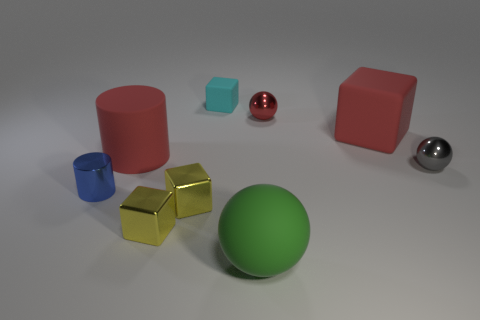Are there more rubber blocks that are left of the tiny rubber thing than tiny red things that are right of the red metal object?
Offer a very short reply. No. What material is the big red cube?
Ensure brevity in your answer.  Rubber. There is a matte object on the right side of the large matte thing in front of the big red matte thing that is on the left side of the tiny rubber object; what shape is it?
Your answer should be very brief. Cube. What number of other things are there of the same material as the tiny blue thing
Offer a very short reply. 4. Do the small thing that is right of the small red metallic thing and the red thing that is left of the big green sphere have the same material?
Make the answer very short. No. How many tiny metal things are both to the right of the large red cube and to the left of the cyan thing?
Keep it short and to the point. 0. Are there any purple things that have the same shape as the red metal thing?
Your answer should be compact. No. The green thing that is the same size as the matte cylinder is what shape?
Provide a succinct answer. Sphere. Is the number of red matte cylinders that are in front of the tiny gray object the same as the number of red metallic balls that are on the left side of the rubber ball?
Your response must be concise. Yes. There is a red rubber thing that is in front of the big object right of the green sphere; how big is it?
Keep it short and to the point. Large. 